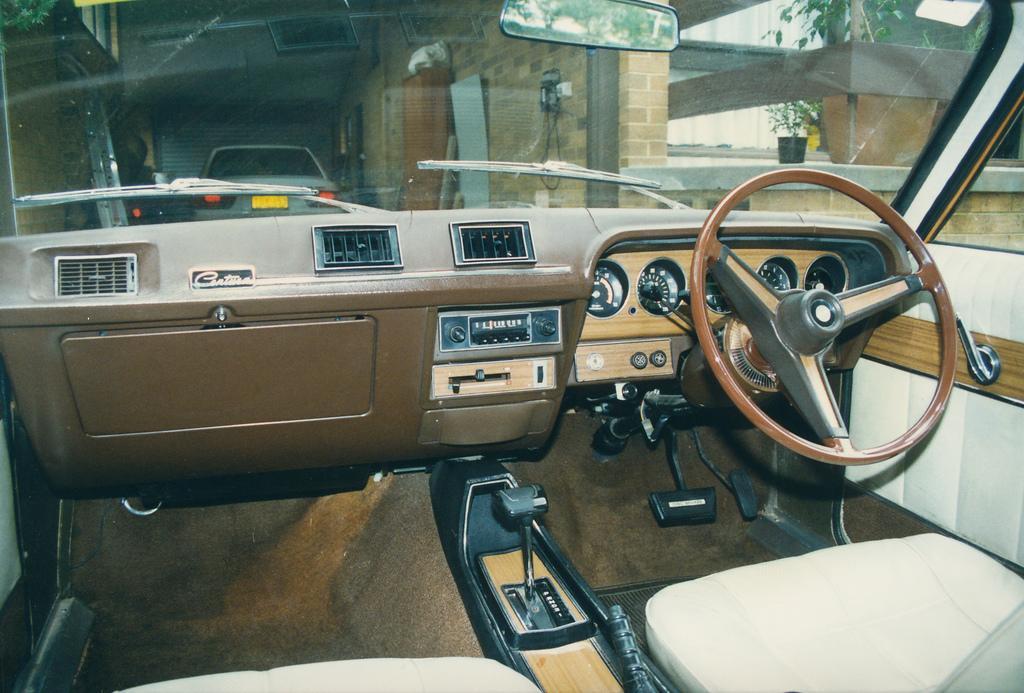How would you summarize this image in a sentence or two? In the picture I can see interior of a car which has a gear rod,steering and some other objects in it and there is another car in front of it and there are some other objects in the background. 